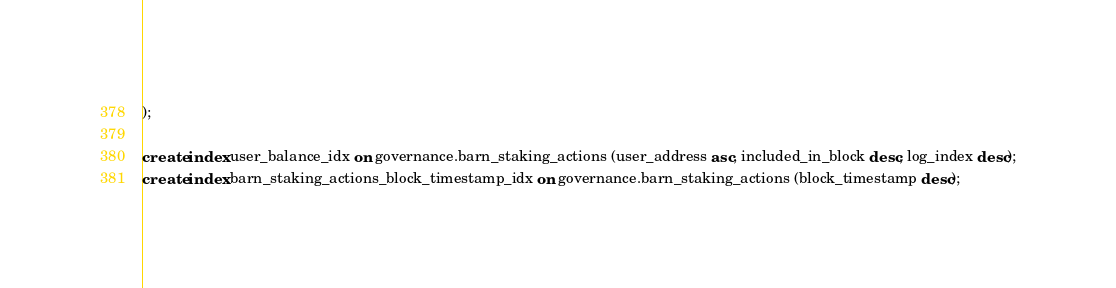Convert code to text. <code><loc_0><loc_0><loc_500><loc_500><_SQL_>);

create index user_balance_idx on governance.barn_staking_actions (user_address asc, included_in_block desc, log_index desc);
create index barn_staking_actions_block_timestamp_idx on governance.barn_staking_actions (block_timestamp desc);
</code> 